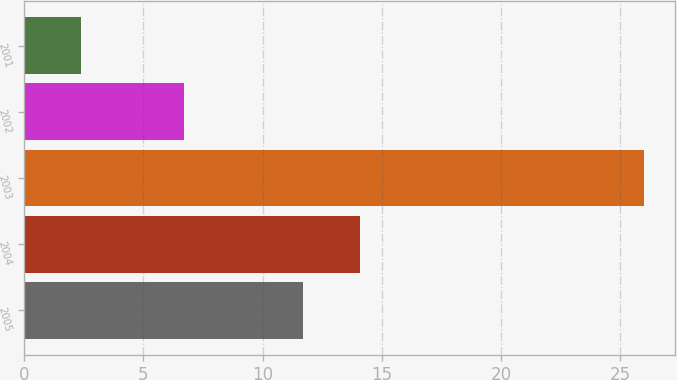<chart> <loc_0><loc_0><loc_500><loc_500><bar_chart><fcel>2005<fcel>2004<fcel>2003<fcel>2002<fcel>2001<nl><fcel>11.7<fcel>14.1<fcel>26<fcel>6.7<fcel>2.4<nl></chart> 